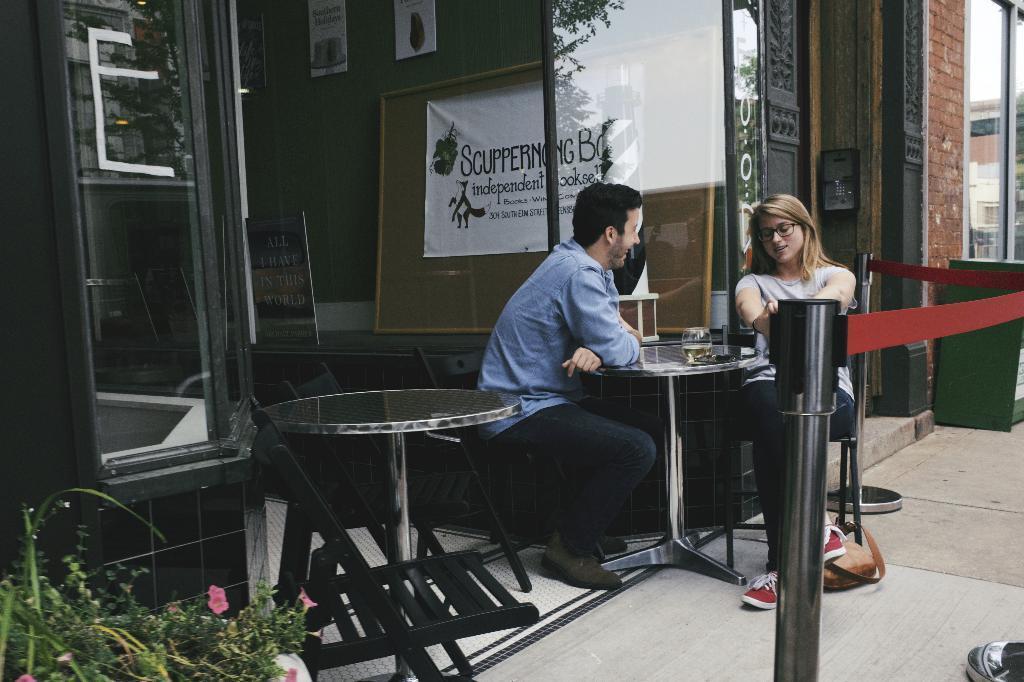In one or two sentences, can you explain what this image depicts? The photo is taken outside a shop. There are two tables and few chairs. On the right side a man and woman sitting around the table. On the table there are glasses. The man is smiling and looking at the woman. There is a barrier around the shop. In the left bottom corner there is a plant with flower. The store is having glass window. Inside the shop there are boards posters. 